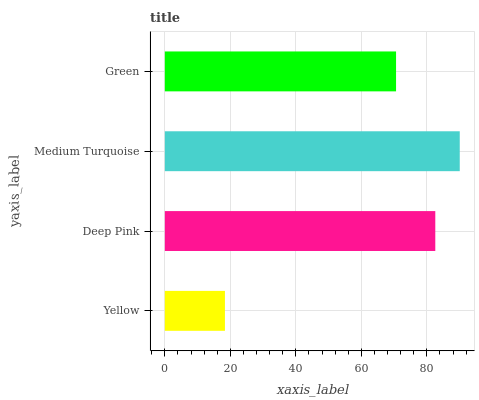Is Yellow the minimum?
Answer yes or no. Yes. Is Medium Turquoise the maximum?
Answer yes or no. Yes. Is Deep Pink the minimum?
Answer yes or no. No. Is Deep Pink the maximum?
Answer yes or no. No. Is Deep Pink greater than Yellow?
Answer yes or no. Yes. Is Yellow less than Deep Pink?
Answer yes or no. Yes. Is Yellow greater than Deep Pink?
Answer yes or no. No. Is Deep Pink less than Yellow?
Answer yes or no. No. Is Deep Pink the high median?
Answer yes or no. Yes. Is Green the low median?
Answer yes or no. Yes. Is Green the high median?
Answer yes or no. No. Is Deep Pink the low median?
Answer yes or no. No. 